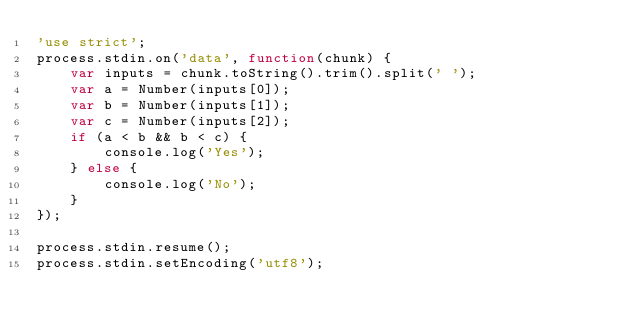Convert code to text. <code><loc_0><loc_0><loc_500><loc_500><_JavaScript_>'use strict';
process.stdin.on('data', function(chunk) {
    var inputs = chunk.toString().trim().split(' ');
    var a = Number(inputs[0]);
    var b = Number(inputs[1]);
    var c = Number(inputs[2]);
    if (a < b && b < c) {
        console.log('Yes');
    } else {
        console.log('No');
    }
});

process.stdin.resume();
process.stdin.setEncoding('utf8');</code> 